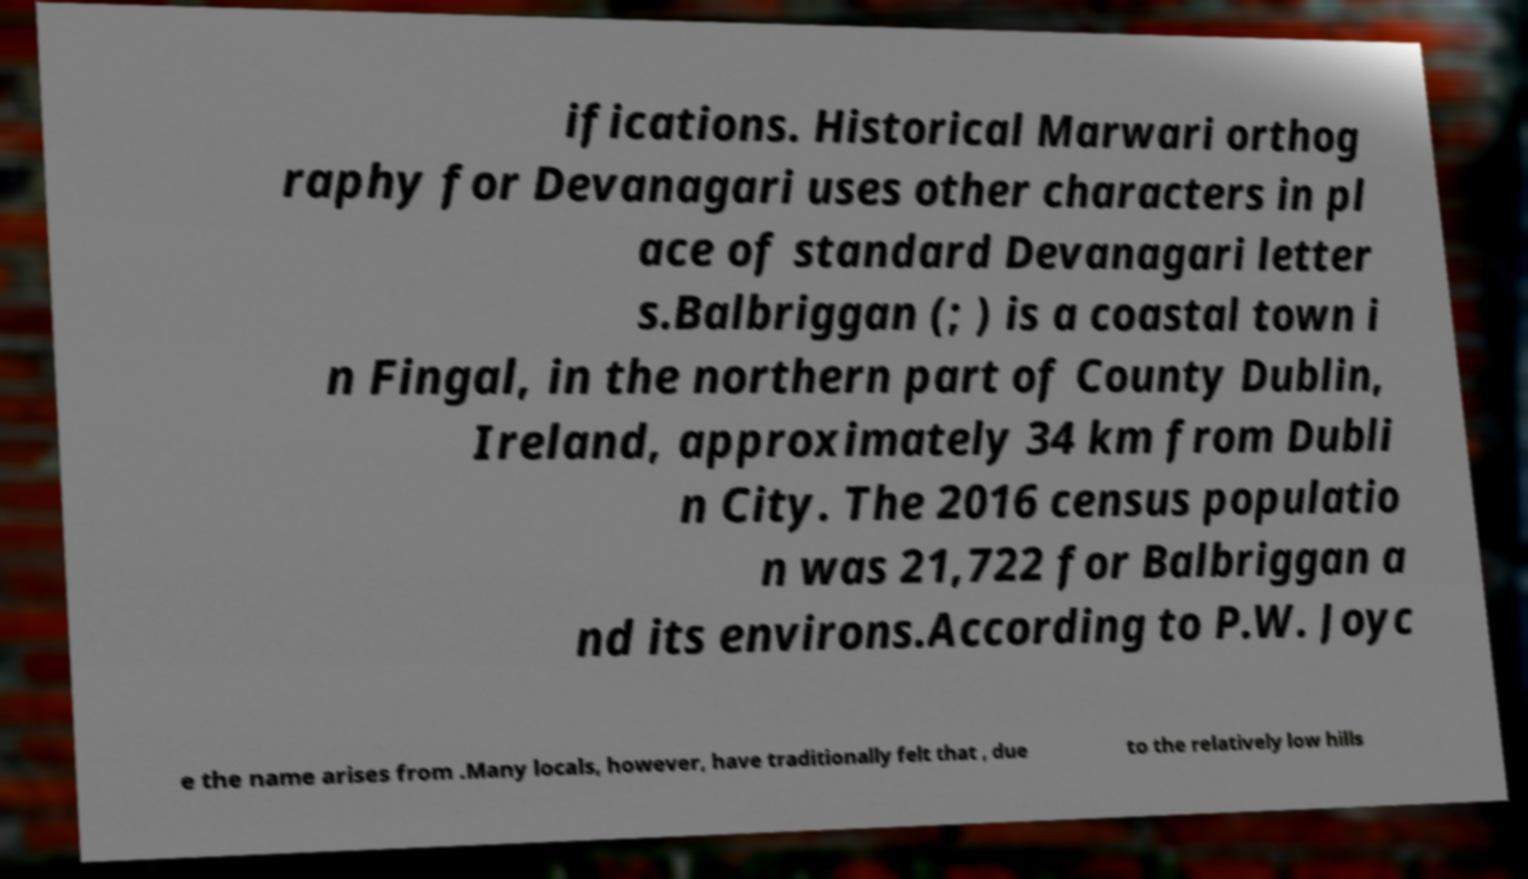Can you read and provide the text displayed in the image?This photo seems to have some interesting text. Can you extract and type it out for me? ifications. Historical Marwari orthog raphy for Devanagari uses other characters in pl ace of standard Devanagari letter s.Balbriggan (; ) is a coastal town i n Fingal, in the northern part of County Dublin, Ireland, approximately 34 km from Dubli n City. The 2016 census populatio n was 21,722 for Balbriggan a nd its environs.According to P.W. Joyc e the name arises from .Many locals, however, have traditionally felt that , due to the relatively low hills 